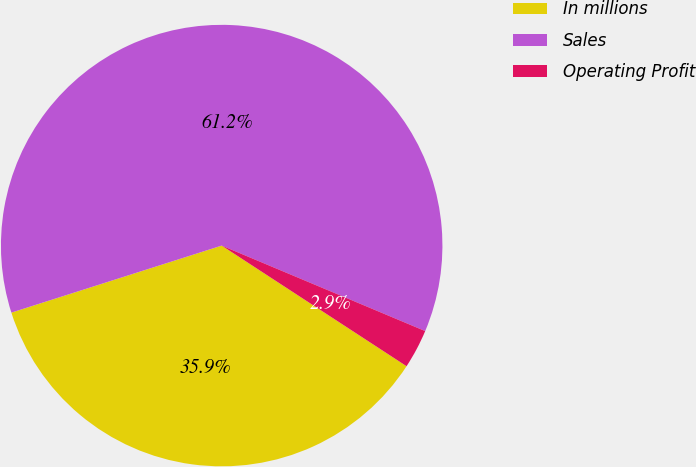Convert chart. <chart><loc_0><loc_0><loc_500><loc_500><pie_chart><fcel>In millions<fcel>Sales<fcel>Operating Profit<nl><fcel>35.89%<fcel>61.24%<fcel>2.87%<nl></chart> 